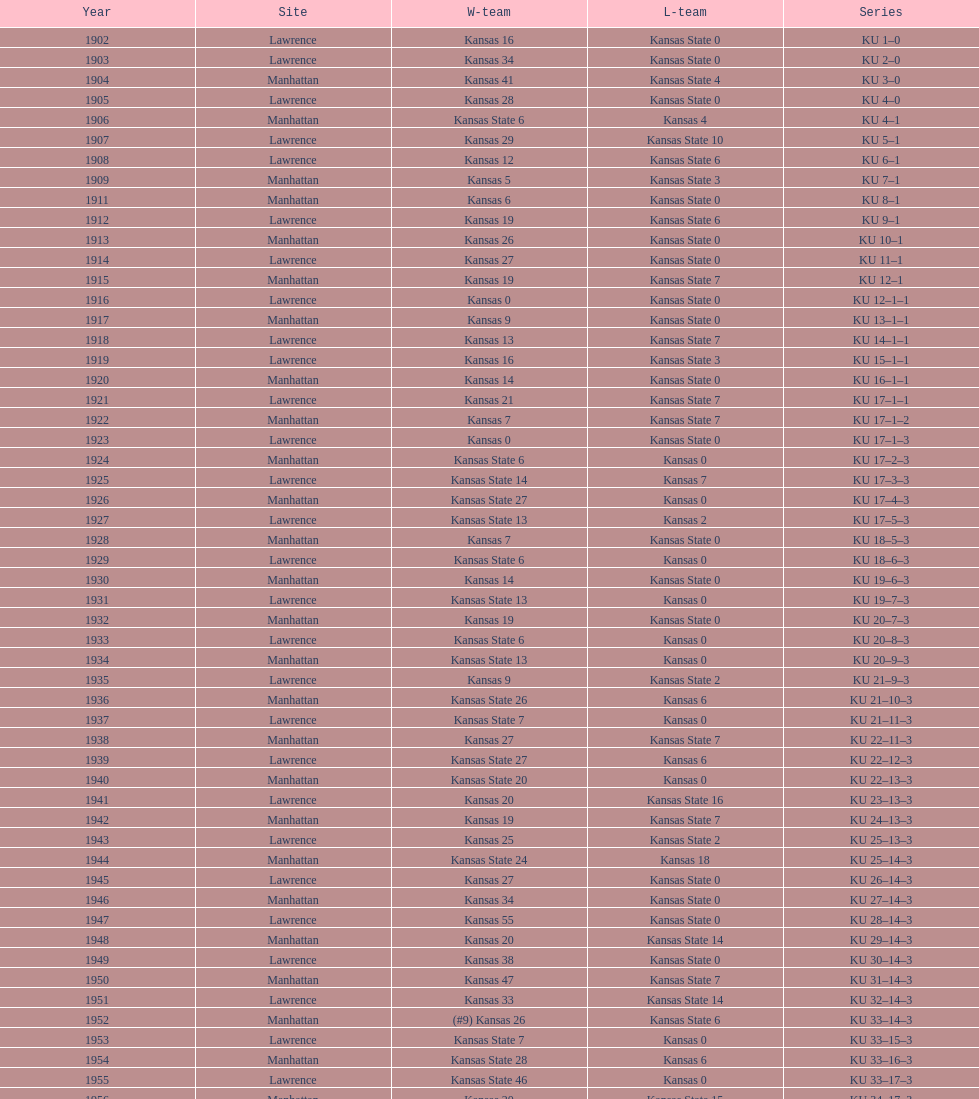Before 1950 what was the most points kansas scored? 55. 